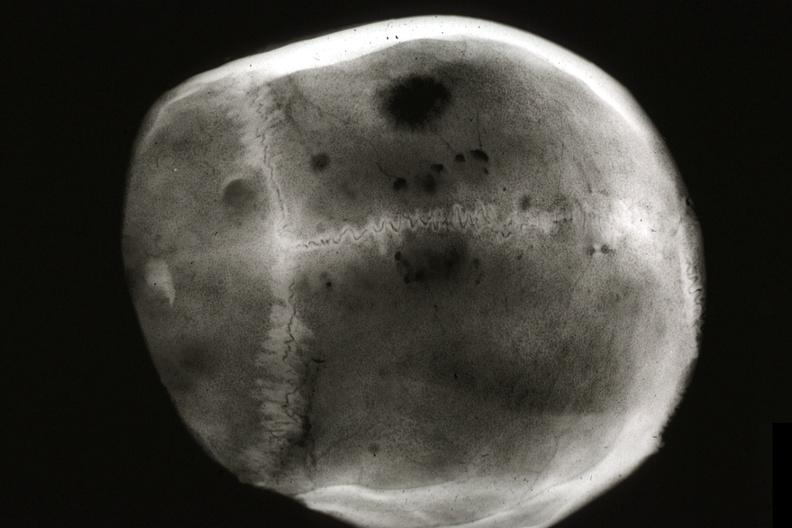what is present?
Answer the question using a single word or phrase. Bone 